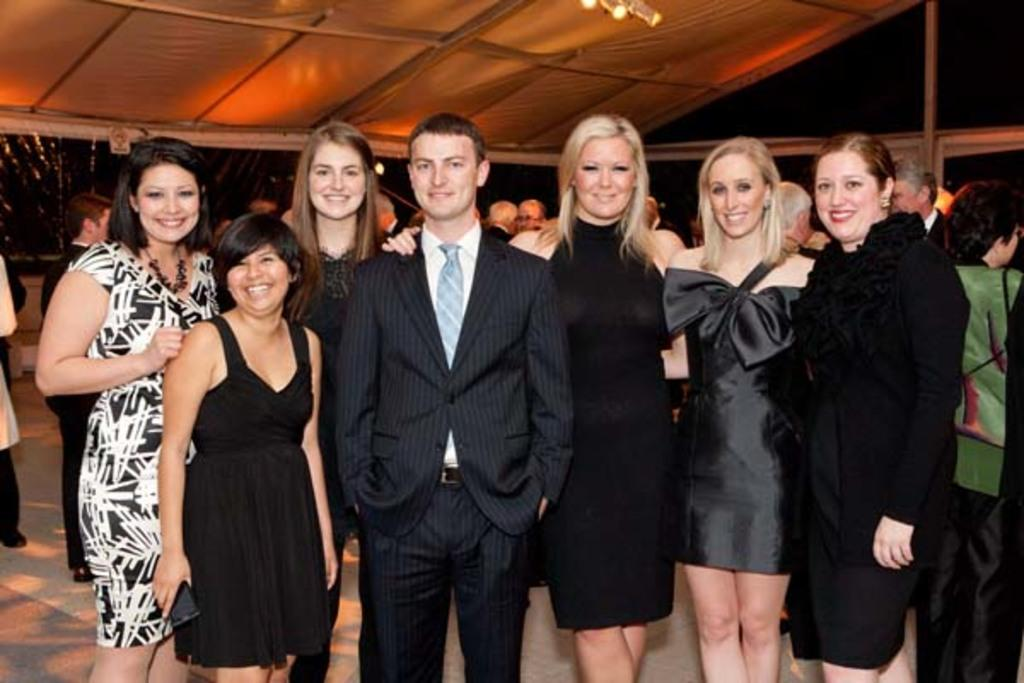How many people are present in the image? There are many people in the image. What is the lady holding in the image? The lady is holding a mobile in the image. What type of shelter is visible in the image? There is a tent in the image. What is visible at the top of the image? There is light visible at the top of the image. What type of base is used for the chalk in the image? There is no chalk present in the image. What color is the copper in the image? There is no copper present in the image. 